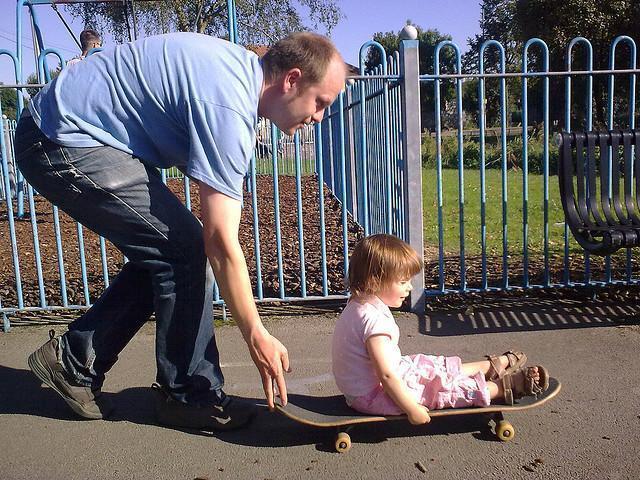How many people can be seen?
Give a very brief answer. 2. 